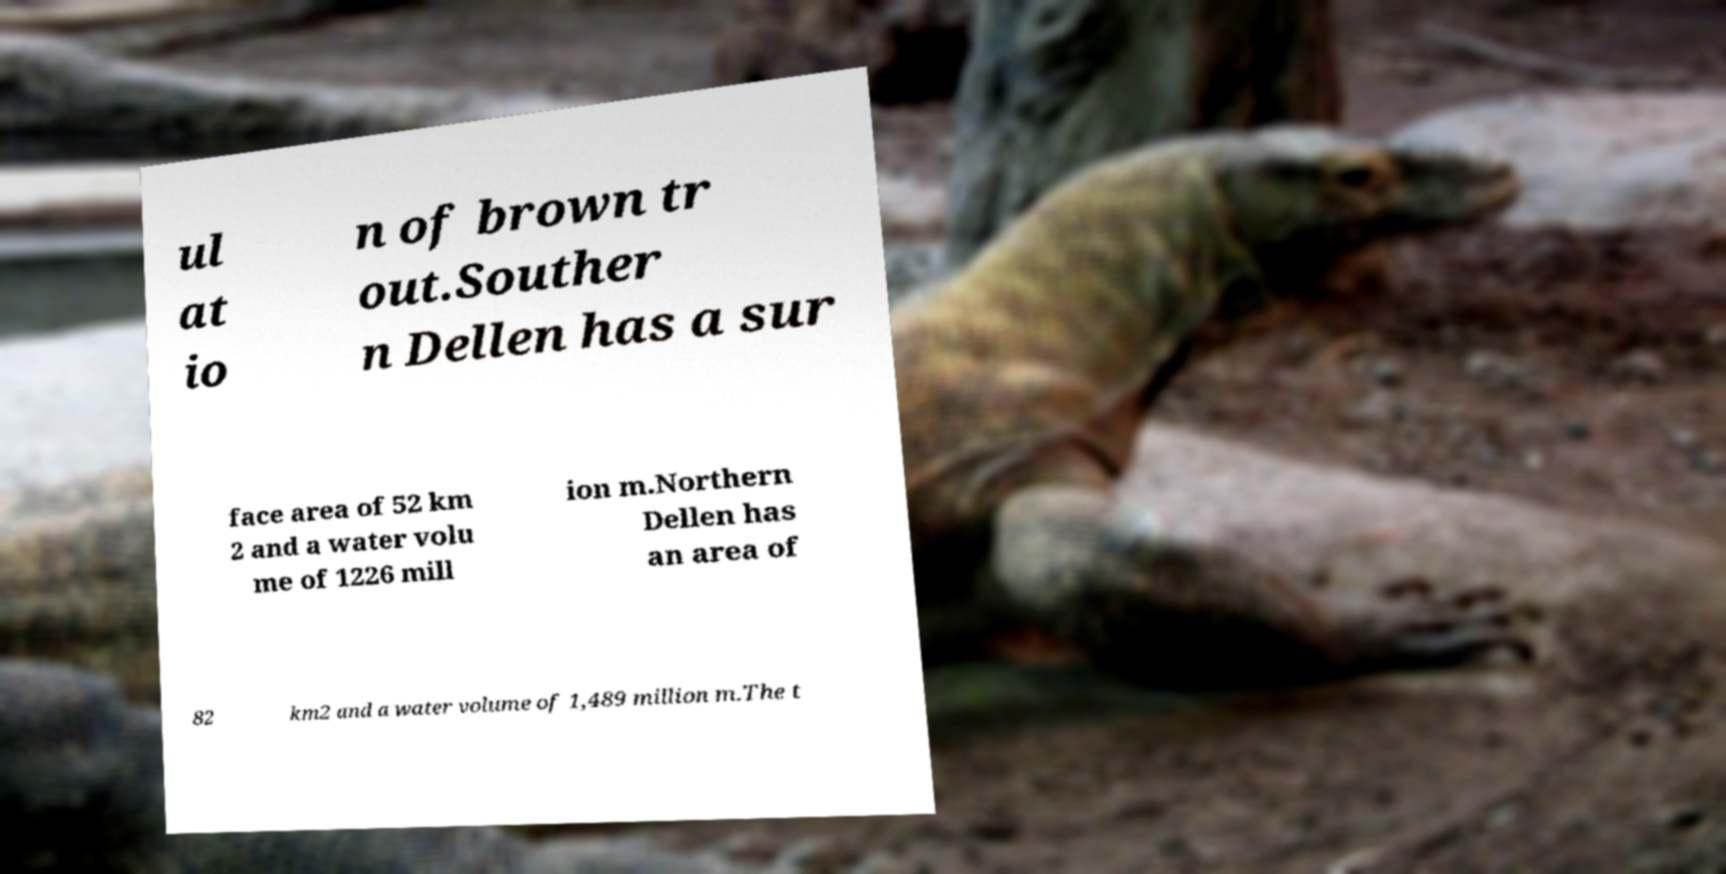I need the written content from this picture converted into text. Can you do that? ul at io n of brown tr out.Souther n Dellen has a sur face area of 52 km 2 and a water volu me of 1226 mill ion m.Northern Dellen has an area of 82 km2 and a water volume of 1,489 million m.The t 